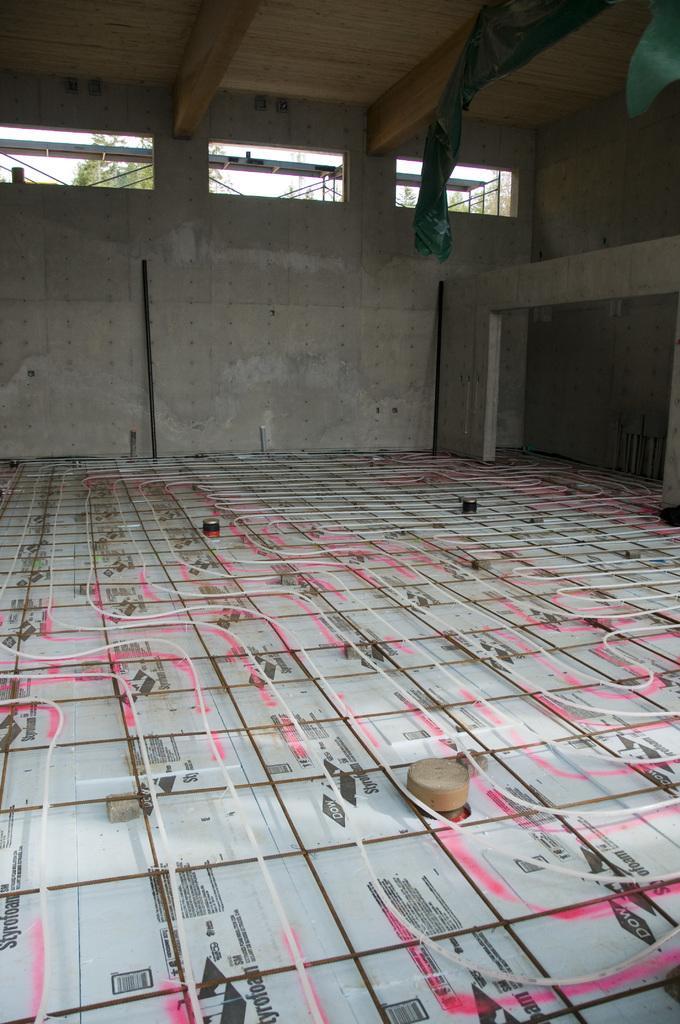How would you summarize this image in a sentence or two? This picture is taken inside the room. In this image, on the right side, we can see a pillar and few clothes. In the background, we can see a window, outside of the window, we can see poles and trees and a sky. At the top, we can see roof, at the bottom, we can see a floor which is made of glass and some stones. 